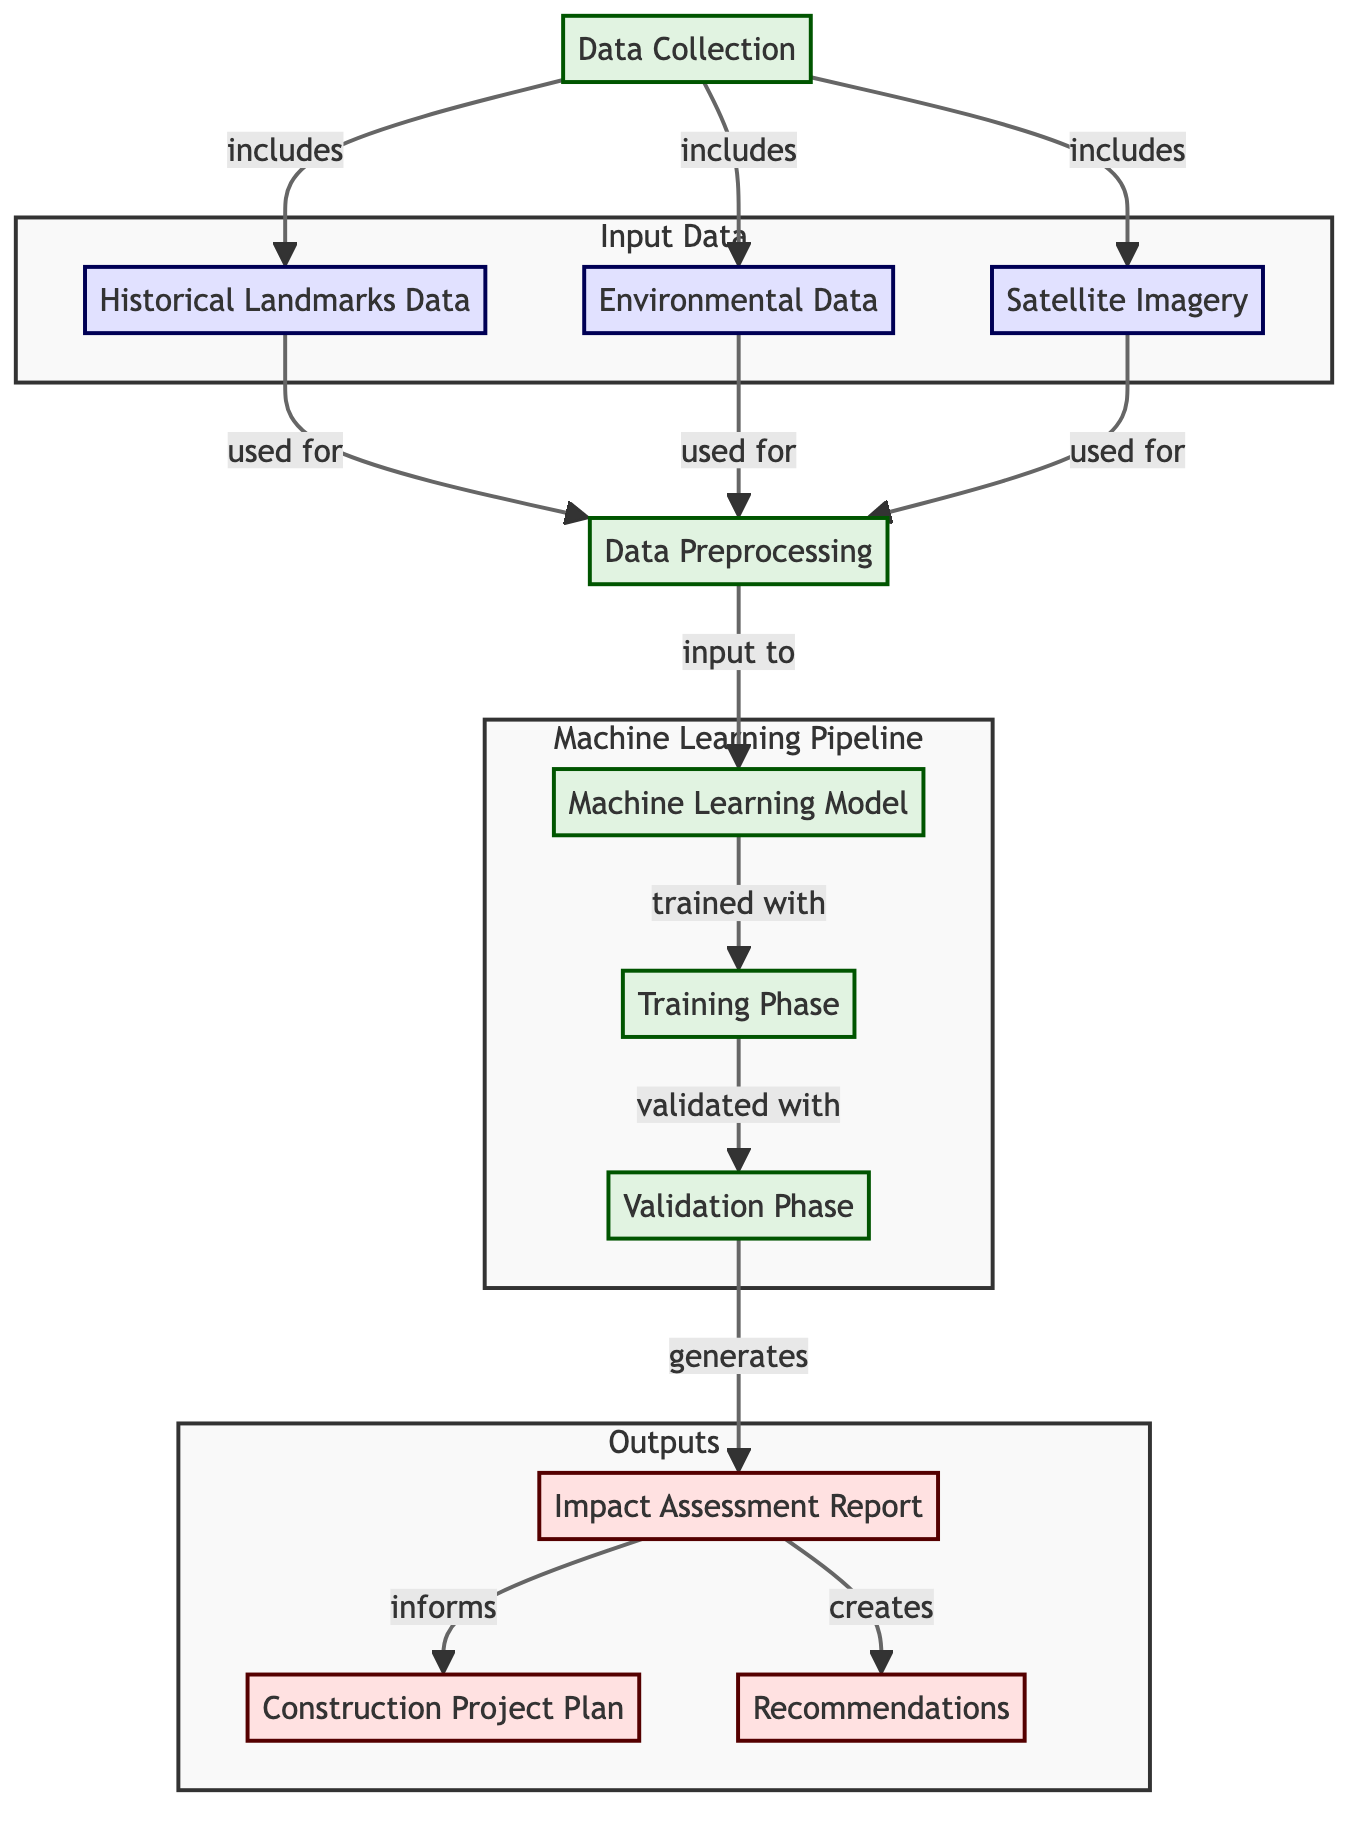What are the three types of input data in the diagram? The diagram lists three types of input data: Historical Landmarks Data, Environmental Data, and Satellite Imagery, which are all shown in the ‘Input Data’ subgraph.
Answer: Historical Landmarks Data, Environmental Data, Satellite Imagery What is the output of the machine learning model? The output generated by the machine learning model is the Impact Assessment Report, which is directly connected to the machine learning model in the flowchart.
Answer: Impact Assessment Report How many nodes are there in total in the diagram? By counting all unique components in the diagram (data collection, input data types, machine learning stages, outputs), there are a total of eight distinct nodes: Data Collection, Historical Landmarks Data, Environmental Data, Satellite Imagery, Machine Learning Model, Training Phase, Validation Phase, and Outputs.
Answer: Eight What relationship is indicated between the Data Preprocessing and Machine Learning Model? According to the diagram, Data Preprocessing serves as an input to the Machine Learning Model, showing that it transforms and prepares the collected data for machine learning tasks.
Answer: Input What phase follows the Training Phase in the machine learning pipeline? The diagram shows that after the Training Phase, the next phase is the Validation Phase, indicating a typical sequence in model training and assessment.
Answer: Validation Phase What does the Impact Assessment Report generate? The diagram indicates that the Impact Assessment Report creates Recommendations, which suggests that the report serves as a basis for proposing actionable items based on the assessed environmental impacts.
Answer: Recommendations What is the first step in the diagram? The first step indicated in the diagram is Data Collection, which encompasses gathering all relevant data needed for the subsequent analysis stages.
Answer: Data Collection Which component is used to inform the Construction Project Plan? The diagram shows that the Impact Assessment Report is used to inform the Construction Project Plan, indicating a direct influence from the outcomes of the assessment on planning decisions.
Answer: Impact Assessment Report 